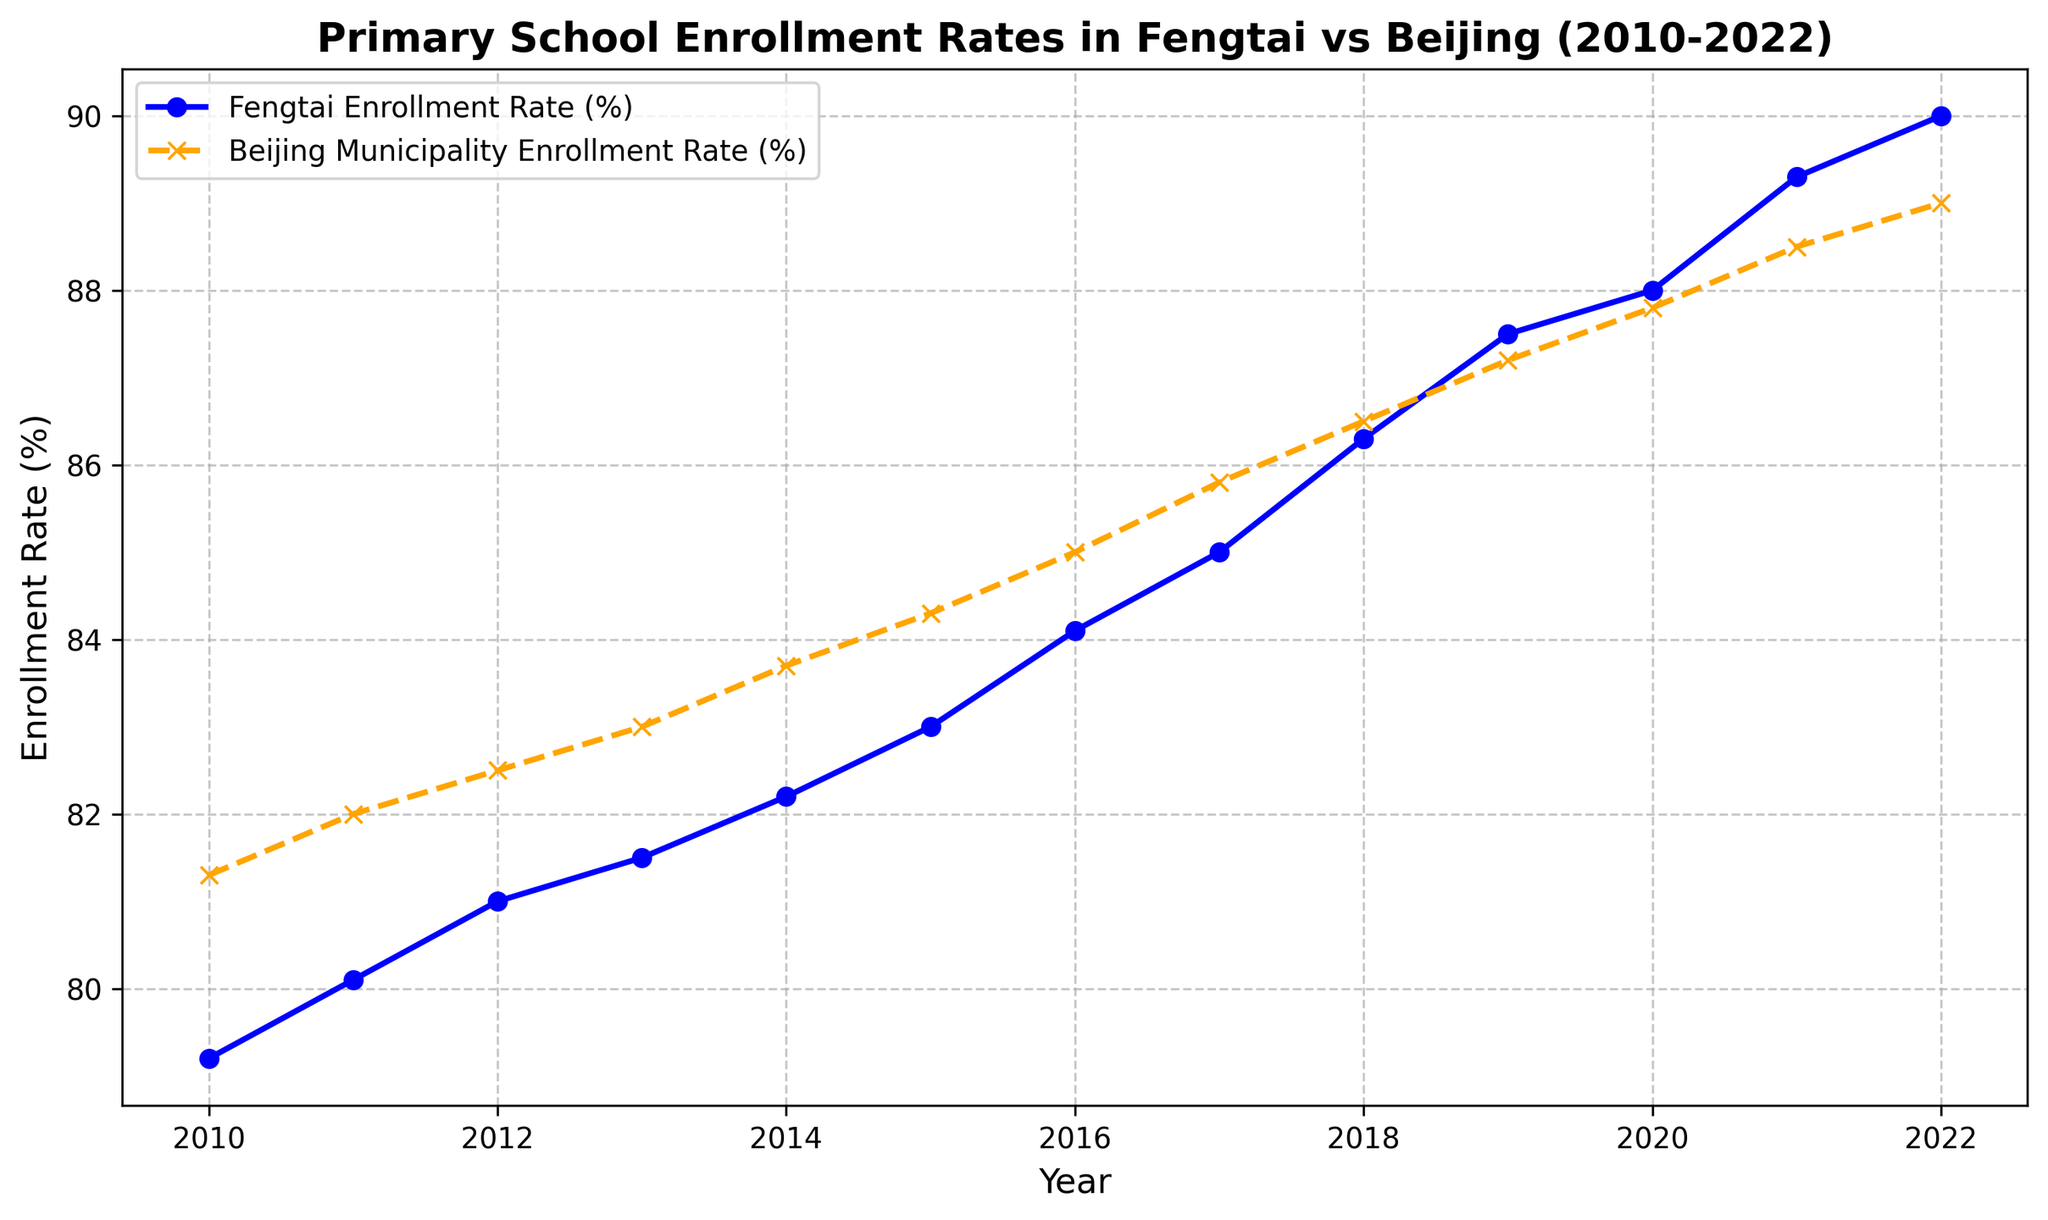What was the enrollment rate in primary schools in Fengtai in 2020? Locate the point corresponding to the year 2020 and refer to the blue line for Fengtai. The enrollment rate at that point is 88.0%.
Answer: 88.0% In which year did Fengtai's enrollment rate surpass the overall Beijing municipality's enrollment rate? Look for the intersection point of the blue and orange lines. The Fengtai enrollment rate (blue line) surpasses the Beijing Municipality enrollment rate (orange line) in the year 2020.
Answer: 2020 By how much did the enrollment rate in Fengtai increase from 2010 to 2022? Subtract the enrollment rate in 2010 from the enrollment rate in 2022 for Fengtai. In 2010, the rate is 79.2%, and in 2022 it is 90.0%. The increase is 90.0% - 79.2% = 10.8%.
Answer: 10.8% How did the trend of the enrollment rate in Fengtai compare to that of the overall Beijing municipality from 2010 to 2022? Both trends generally increase over the years. Fengtai's line (blue) consistently shows upward movement, similar to Beijing's line (orange). However, Fengtai's rate increases more sharply, particularly after 2014.
Answer: Both increased, but Fengtai increased more sharply What is the difference between the enrollment rates of Fengtai and Beijing Municipality in 2012? Find the values for 2012 for both Fengtai (81.0%) and Beijing Municipality (82.5%) and subtract the former from the latter. 82.5% - 81.0% = 1.5%.
Answer: 1.5% Which year had the smallest difference between the enrollment rates of Fengtai and Beijing Municipality? Observe the gaps between the blue and orange lines across the years. The smallest difference is visually smallest around the year 2018, with rates of approximately 86.3% (Fengtai) and 86.5% (Beijing Municipality). The difference is 0.2%.
Answer: 2018 What was the rate of growth in Fengtai's enrollment from 2015 to 2022? Subtract the rate in 2015 from the rate in 2022. The rate in 2015 is 83.0%, and in 2022 it is 90.0%. The growth rate is (90.0% - 83.0%) = 7.0%.
Answer: 7.0% How many years did it take for Fengtai's enrollment rate to increase by 10% from its 2010 rate? The enrollment rate in 2010 is 79.2%. Adding 10% to this, we get 89.2%. Fengtai's rate reached or exceeded 89.2% in the year 2021. So, it took from 2010 to 2021, which is 11 years.
Answer: 11 years What is the median enrollment rate for Fengtai from 2010 to 2022? List the enrollment rates in ascending order and find the middle value. The rates are: 79.2, 80.1, 81.0, 81.5, 82.2, 83.0, 84.1, 85.0, 86.3, 87.5, 88.0, 89.3, 90.0. The middle value, or 7th value in this ordered list is 84.1%.
Answer: 84.1% In which year did the overall Beijing municipality have the highest enrollment rate and what was it? Look for the peak point on the orange line representing the Beijing Municipality and note the highest value. The peak value is in 2021, with an enrollment rate of 88.5%.
Answer: 2021, 88.5% 